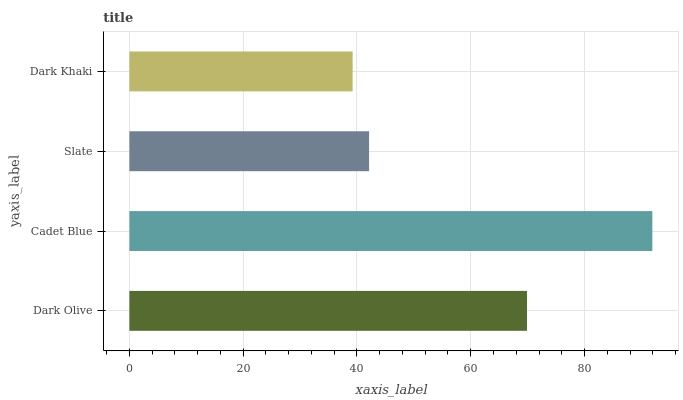Is Dark Khaki the minimum?
Answer yes or no. Yes. Is Cadet Blue the maximum?
Answer yes or no. Yes. Is Slate the minimum?
Answer yes or no. No. Is Slate the maximum?
Answer yes or no. No. Is Cadet Blue greater than Slate?
Answer yes or no. Yes. Is Slate less than Cadet Blue?
Answer yes or no. Yes. Is Slate greater than Cadet Blue?
Answer yes or no. No. Is Cadet Blue less than Slate?
Answer yes or no. No. Is Dark Olive the high median?
Answer yes or no. Yes. Is Slate the low median?
Answer yes or no. Yes. Is Slate the high median?
Answer yes or no. No. Is Dark Khaki the low median?
Answer yes or no. No. 